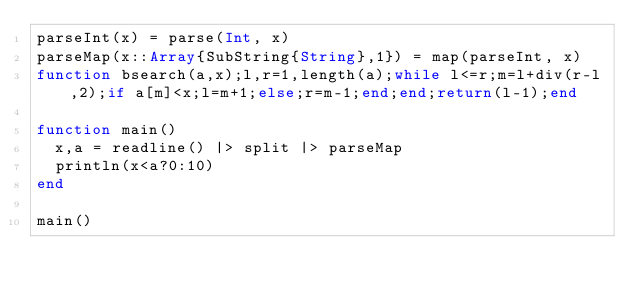Convert code to text. <code><loc_0><loc_0><loc_500><loc_500><_Julia_>parseInt(x) = parse(Int, x)
parseMap(x::Array{SubString{String},1}) = map(parseInt, x)
function bsearch(a,x);l,r=1,length(a);while l<=r;m=l+div(r-l,2);if a[m]<x;l=m+1;else;r=m-1;end;end;return(l-1);end

function main()
	x,a = readline() |> split |> parseMap
	println(x<a?0:10)
end

main()</code> 